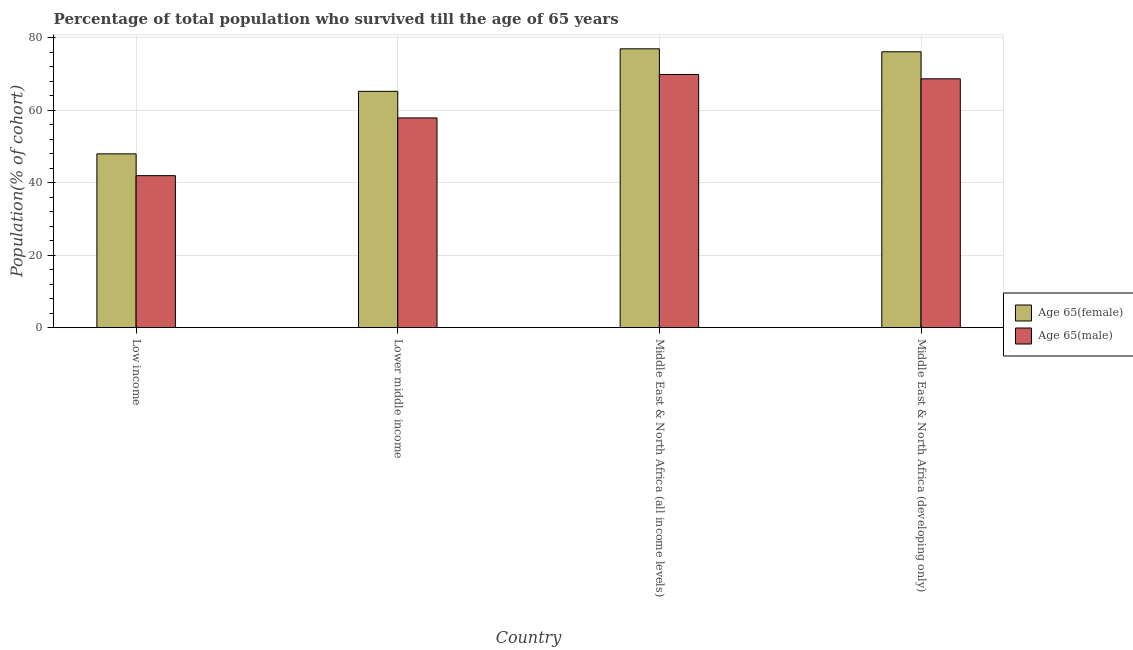How many different coloured bars are there?
Ensure brevity in your answer.  2. How many groups of bars are there?
Offer a very short reply. 4. Are the number of bars per tick equal to the number of legend labels?
Provide a short and direct response. Yes. Are the number of bars on each tick of the X-axis equal?
Provide a short and direct response. Yes. How many bars are there on the 2nd tick from the right?
Provide a succinct answer. 2. What is the label of the 4th group of bars from the left?
Your response must be concise. Middle East & North Africa (developing only). In how many cases, is the number of bars for a given country not equal to the number of legend labels?
Ensure brevity in your answer.  0. What is the percentage of male population who survived till age of 65 in Middle East & North Africa (developing only)?
Your answer should be compact. 68.67. Across all countries, what is the maximum percentage of male population who survived till age of 65?
Your answer should be very brief. 69.87. Across all countries, what is the minimum percentage of female population who survived till age of 65?
Keep it short and to the point. 47.96. In which country was the percentage of female population who survived till age of 65 maximum?
Your response must be concise. Middle East & North Africa (all income levels). What is the total percentage of male population who survived till age of 65 in the graph?
Provide a succinct answer. 238.37. What is the difference between the percentage of male population who survived till age of 65 in Lower middle income and that in Middle East & North Africa (developing only)?
Give a very brief answer. -10.79. What is the difference between the percentage of male population who survived till age of 65 in Middle East & North Africa (developing only) and the percentage of female population who survived till age of 65 in Middle East & North Africa (all income levels)?
Give a very brief answer. -8.28. What is the average percentage of male population who survived till age of 65 per country?
Make the answer very short. 59.59. What is the difference between the percentage of female population who survived till age of 65 and percentage of male population who survived till age of 65 in Middle East & North Africa (all income levels)?
Your response must be concise. 7.08. What is the ratio of the percentage of male population who survived till age of 65 in Middle East & North Africa (all income levels) to that in Middle East & North Africa (developing only)?
Give a very brief answer. 1.02. Is the percentage of male population who survived till age of 65 in Low income less than that in Lower middle income?
Keep it short and to the point. Yes. Is the difference between the percentage of male population who survived till age of 65 in Low income and Lower middle income greater than the difference between the percentage of female population who survived till age of 65 in Low income and Lower middle income?
Your answer should be compact. Yes. What is the difference between the highest and the second highest percentage of female population who survived till age of 65?
Offer a terse response. 0.82. What is the difference between the highest and the lowest percentage of male population who survived till age of 65?
Keep it short and to the point. 27.92. In how many countries, is the percentage of male population who survived till age of 65 greater than the average percentage of male population who survived till age of 65 taken over all countries?
Offer a very short reply. 2. Is the sum of the percentage of female population who survived till age of 65 in Lower middle income and Middle East & North Africa (all income levels) greater than the maximum percentage of male population who survived till age of 65 across all countries?
Your answer should be very brief. Yes. What does the 1st bar from the left in Low income represents?
Offer a terse response. Age 65(female). What does the 1st bar from the right in Lower middle income represents?
Your response must be concise. Age 65(male). What is the difference between two consecutive major ticks on the Y-axis?
Provide a succinct answer. 20. Are the values on the major ticks of Y-axis written in scientific E-notation?
Make the answer very short. No. Does the graph contain any zero values?
Give a very brief answer. No. Does the graph contain grids?
Keep it short and to the point. Yes. Where does the legend appear in the graph?
Your response must be concise. Center right. How are the legend labels stacked?
Ensure brevity in your answer.  Vertical. What is the title of the graph?
Provide a short and direct response. Percentage of total population who survived till the age of 65 years. Does "Net National savings" appear as one of the legend labels in the graph?
Your answer should be very brief. No. What is the label or title of the X-axis?
Provide a succinct answer. Country. What is the label or title of the Y-axis?
Offer a terse response. Population(% of cohort). What is the Population(% of cohort) of Age 65(female) in Low income?
Provide a succinct answer. 47.96. What is the Population(% of cohort) in Age 65(male) in Low income?
Offer a terse response. 41.95. What is the Population(% of cohort) in Age 65(female) in Lower middle income?
Make the answer very short. 65.22. What is the Population(% of cohort) in Age 65(male) in Lower middle income?
Your response must be concise. 57.88. What is the Population(% of cohort) in Age 65(female) in Middle East & North Africa (all income levels)?
Your response must be concise. 76.95. What is the Population(% of cohort) in Age 65(male) in Middle East & North Africa (all income levels)?
Your response must be concise. 69.87. What is the Population(% of cohort) of Age 65(female) in Middle East & North Africa (developing only)?
Offer a terse response. 76.13. What is the Population(% of cohort) in Age 65(male) in Middle East & North Africa (developing only)?
Your answer should be compact. 68.67. Across all countries, what is the maximum Population(% of cohort) in Age 65(female)?
Offer a very short reply. 76.95. Across all countries, what is the maximum Population(% of cohort) in Age 65(male)?
Ensure brevity in your answer.  69.87. Across all countries, what is the minimum Population(% of cohort) of Age 65(female)?
Your answer should be compact. 47.96. Across all countries, what is the minimum Population(% of cohort) in Age 65(male)?
Give a very brief answer. 41.95. What is the total Population(% of cohort) of Age 65(female) in the graph?
Your response must be concise. 266.26. What is the total Population(% of cohort) in Age 65(male) in the graph?
Offer a very short reply. 238.37. What is the difference between the Population(% of cohort) of Age 65(female) in Low income and that in Lower middle income?
Make the answer very short. -17.25. What is the difference between the Population(% of cohort) in Age 65(male) in Low income and that in Lower middle income?
Offer a terse response. -15.93. What is the difference between the Population(% of cohort) of Age 65(female) in Low income and that in Middle East & North Africa (all income levels)?
Provide a succinct answer. -28.99. What is the difference between the Population(% of cohort) in Age 65(male) in Low income and that in Middle East & North Africa (all income levels)?
Give a very brief answer. -27.92. What is the difference between the Population(% of cohort) in Age 65(female) in Low income and that in Middle East & North Africa (developing only)?
Keep it short and to the point. -28.17. What is the difference between the Population(% of cohort) of Age 65(male) in Low income and that in Middle East & North Africa (developing only)?
Keep it short and to the point. -26.72. What is the difference between the Population(% of cohort) of Age 65(female) in Lower middle income and that in Middle East & North Africa (all income levels)?
Your answer should be very brief. -11.73. What is the difference between the Population(% of cohort) of Age 65(male) in Lower middle income and that in Middle East & North Africa (all income levels)?
Your response must be concise. -11.99. What is the difference between the Population(% of cohort) in Age 65(female) in Lower middle income and that in Middle East & North Africa (developing only)?
Provide a short and direct response. -10.91. What is the difference between the Population(% of cohort) in Age 65(male) in Lower middle income and that in Middle East & North Africa (developing only)?
Offer a very short reply. -10.79. What is the difference between the Population(% of cohort) of Age 65(female) in Middle East & North Africa (all income levels) and that in Middle East & North Africa (developing only)?
Give a very brief answer. 0.82. What is the difference between the Population(% of cohort) of Age 65(male) in Middle East & North Africa (all income levels) and that in Middle East & North Africa (developing only)?
Keep it short and to the point. 1.2. What is the difference between the Population(% of cohort) in Age 65(female) in Low income and the Population(% of cohort) in Age 65(male) in Lower middle income?
Ensure brevity in your answer.  -9.92. What is the difference between the Population(% of cohort) in Age 65(female) in Low income and the Population(% of cohort) in Age 65(male) in Middle East & North Africa (all income levels)?
Provide a succinct answer. -21.91. What is the difference between the Population(% of cohort) of Age 65(female) in Low income and the Population(% of cohort) of Age 65(male) in Middle East & North Africa (developing only)?
Keep it short and to the point. -20.71. What is the difference between the Population(% of cohort) in Age 65(female) in Lower middle income and the Population(% of cohort) in Age 65(male) in Middle East & North Africa (all income levels)?
Provide a short and direct response. -4.65. What is the difference between the Population(% of cohort) in Age 65(female) in Lower middle income and the Population(% of cohort) in Age 65(male) in Middle East & North Africa (developing only)?
Provide a short and direct response. -3.45. What is the difference between the Population(% of cohort) of Age 65(female) in Middle East & North Africa (all income levels) and the Population(% of cohort) of Age 65(male) in Middle East & North Africa (developing only)?
Provide a succinct answer. 8.28. What is the average Population(% of cohort) in Age 65(female) per country?
Make the answer very short. 66.57. What is the average Population(% of cohort) in Age 65(male) per country?
Offer a very short reply. 59.59. What is the difference between the Population(% of cohort) of Age 65(female) and Population(% of cohort) of Age 65(male) in Low income?
Offer a very short reply. 6.01. What is the difference between the Population(% of cohort) of Age 65(female) and Population(% of cohort) of Age 65(male) in Lower middle income?
Keep it short and to the point. 7.34. What is the difference between the Population(% of cohort) in Age 65(female) and Population(% of cohort) in Age 65(male) in Middle East & North Africa (all income levels)?
Your response must be concise. 7.08. What is the difference between the Population(% of cohort) in Age 65(female) and Population(% of cohort) in Age 65(male) in Middle East & North Africa (developing only)?
Provide a short and direct response. 7.46. What is the ratio of the Population(% of cohort) of Age 65(female) in Low income to that in Lower middle income?
Your answer should be very brief. 0.74. What is the ratio of the Population(% of cohort) of Age 65(male) in Low income to that in Lower middle income?
Ensure brevity in your answer.  0.72. What is the ratio of the Population(% of cohort) of Age 65(female) in Low income to that in Middle East & North Africa (all income levels)?
Your response must be concise. 0.62. What is the ratio of the Population(% of cohort) in Age 65(male) in Low income to that in Middle East & North Africa (all income levels)?
Ensure brevity in your answer.  0.6. What is the ratio of the Population(% of cohort) of Age 65(female) in Low income to that in Middle East & North Africa (developing only)?
Make the answer very short. 0.63. What is the ratio of the Population(% of cohort) in Age 65(male) in Low income to that in Middle East & North Africa (developing only)?
Provide a short and direct response. 0.61. What is the ratio of the Population(% of cohort) of Age 65(female) in Lower middle income to that in Middle East & North Africa (all income levels)?
Ensure brevity in your answer.  0.85. What is the ratio of the Population(% of cohort) in Age 65(male) in Lower middle income to that in Middle East & North Africa (all income levels)?
Ensure brevity in your answer.  0.83. What is the ratio of the Population(% of cohort) of Age 65(female) in Lower middle income to that in Middle East & North Africa (developing only)?
Keep it short and to the point. 0.86. What is the ratio of the Population(% of cohort) in Age 65(male) in Lower middle income to that in Middle East & North Africa (developing only)?
Offer a very short reply. 0.84. What is the ratio of the Population(% of cohort) of Age 65(female) in Middle East & North Africa (all income levels) to that in Middle East & North Africa (developing only)?
Keep it short and to the point. 1.01. What is the ratio of the Population(% of cohort) in Age 65(male) in Middle East & North Africa (all income levels) to that in Middle East & North Africa (developing only)?
Offer a very short reply. 1.02. What is the difference between the highest and the second highest Population(% of cohort) of Age 65(female)?
Your answer should be very brief. 0.82. What is the difference between the highest and the second highest Population(% of cohort) in Age 65(male)?
Your response must be concise. 1.2. What is the difference between the highest and the lowest Population(% of cohort) of Age 65(female)?
Offer a very short reply. 28.99. What is the difference between the highest and the lowest Population(% of cohort) in Age 65(male)?
Offer a terse response. 27.92. 